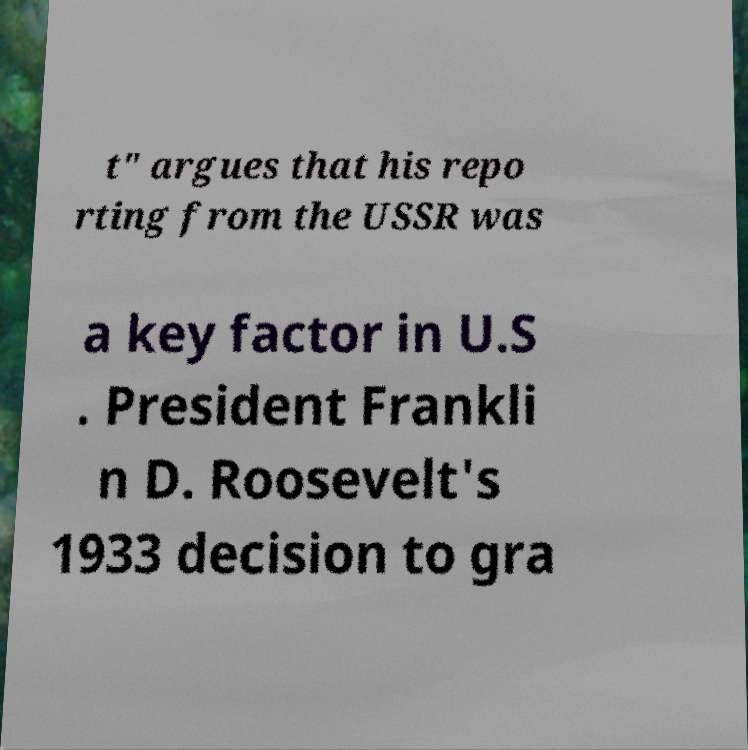There's text embedded in this image that I need extracted. Can you transcribe it verbatim? t" argues that his repo rting from the USSR was a key factor in U.S . President Frankli n D. Roosevelt's 1933 decision to gra 